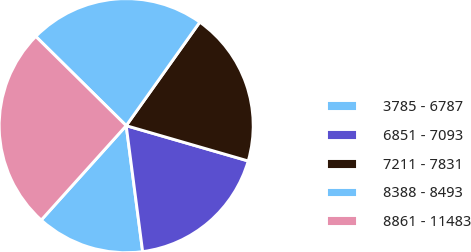<chart> <loc_0><loc_0><loc_500><loc_500><pie_chart><fcel>3785 - 6787<fcel>6851 - 7093<fcel>7211 - 7831<fcel>8388 - 8493<fcel>8861 - 11483<nl><fcel>13.73%<fcel>18.45%<fcel>19.65%<fcel>22.44%<fcel>25.73%<nl></chart> 